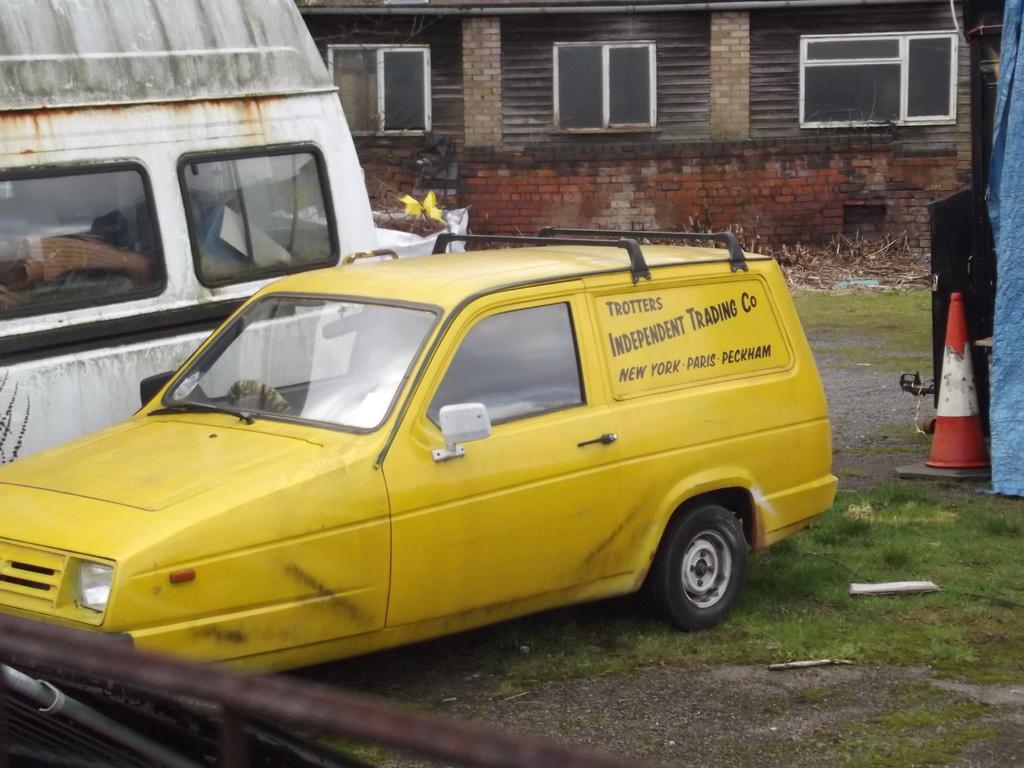What company is displayed?
Ensure brevity in your answer.  Trotters independent trading co. Is there are stand or not?
Make the answer very short. Unanswerable. 